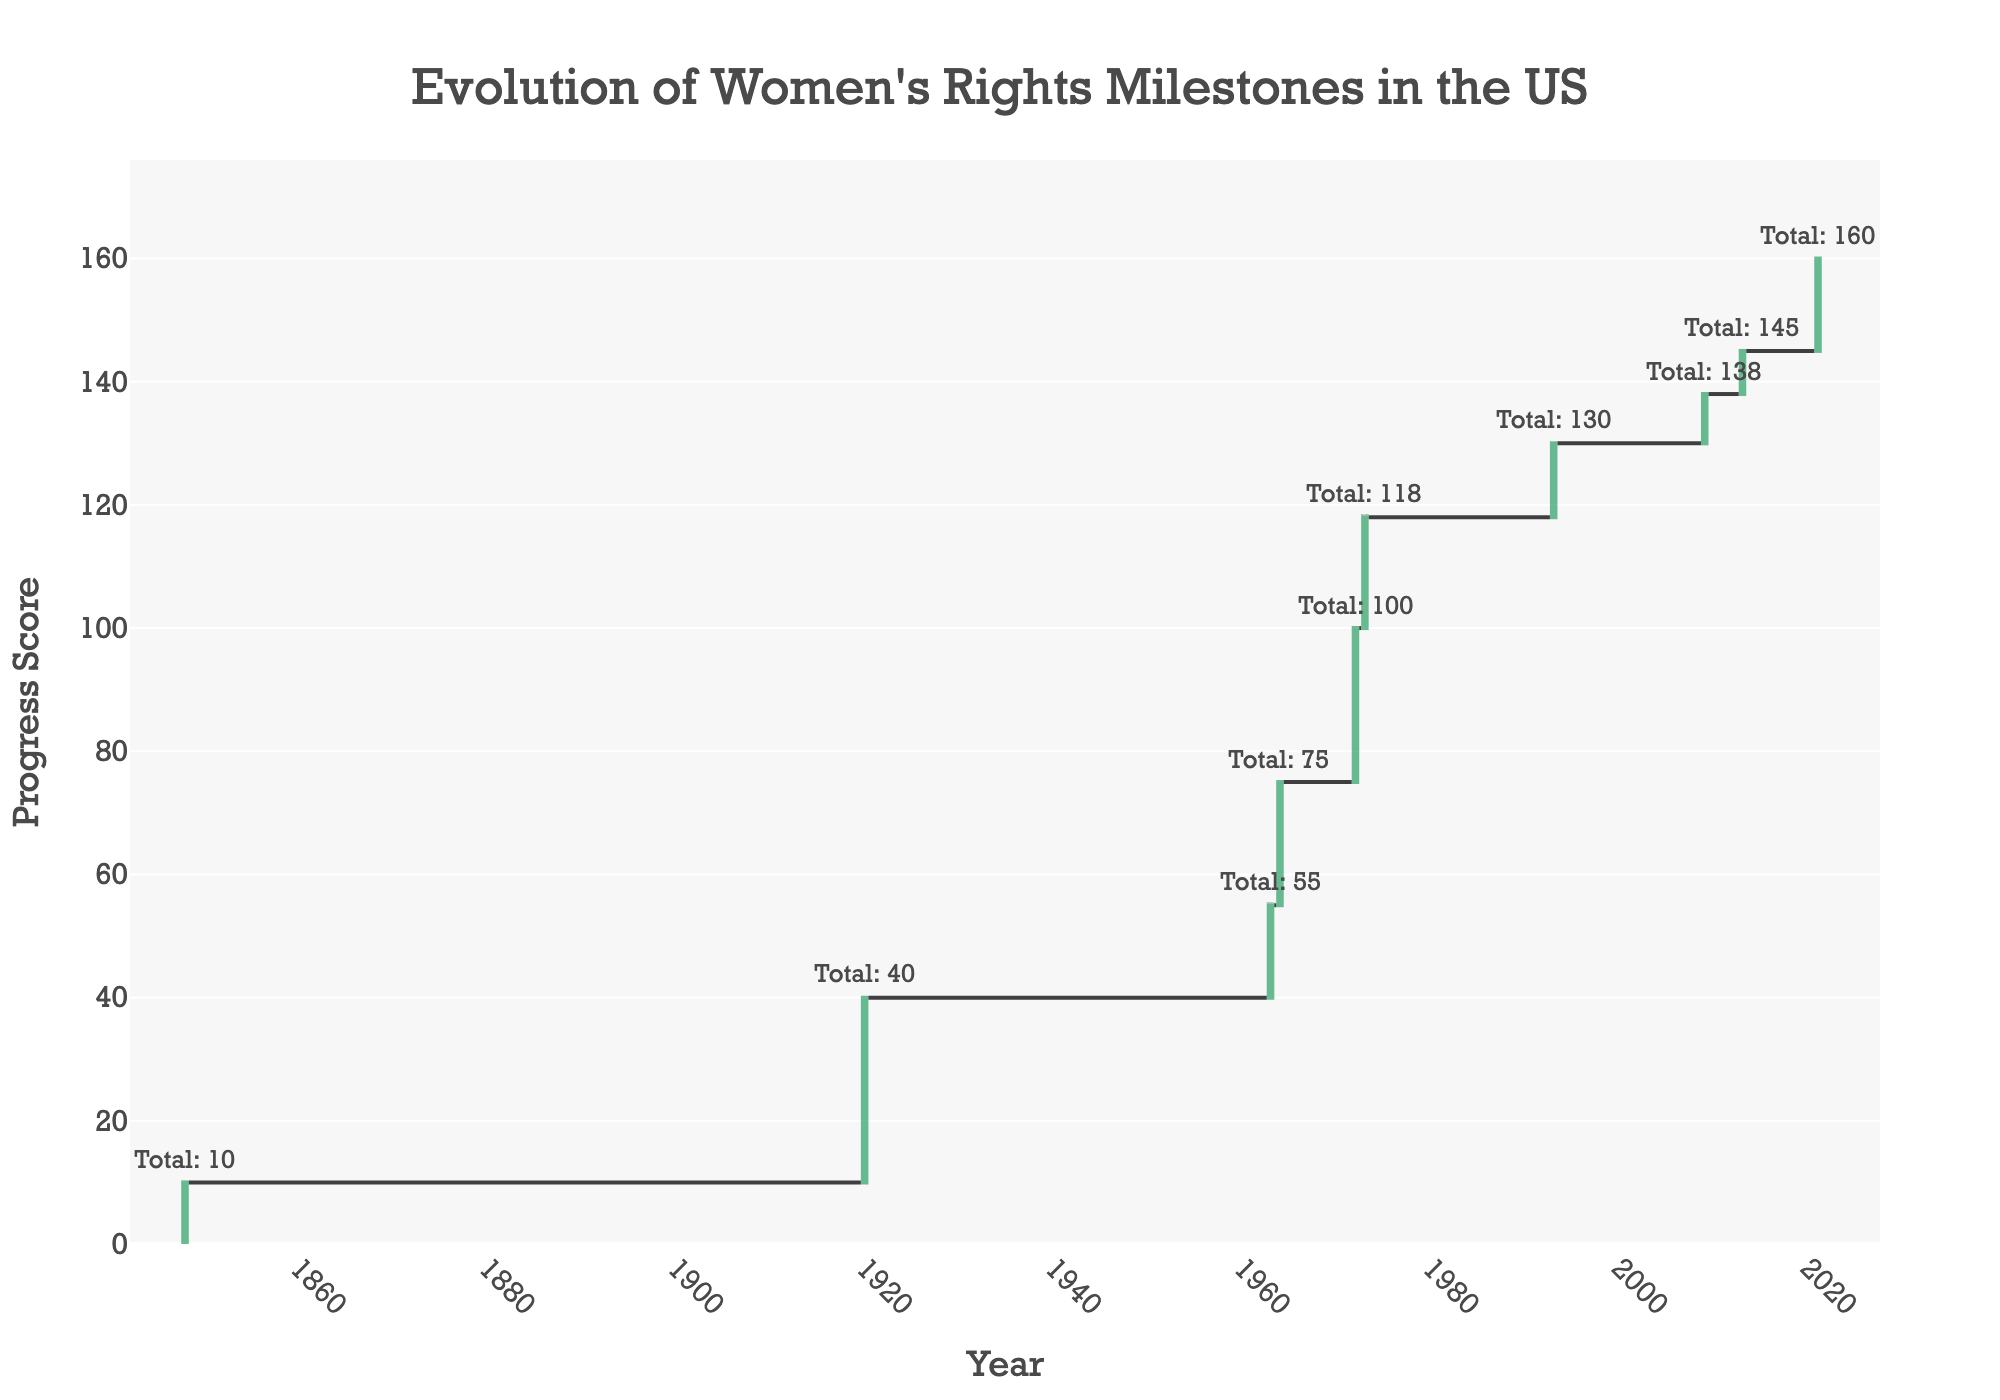What is the title of the chart? The title is prominently displayed at the top of the chart, summarizing the main subject and helping viewers immediately understand what the chart presents. The title of the chart is "Evolution of Women's Rights Milestones in the US."
Answer: Evolution of Women's Rights Milestones in the US In which year did the Seneca Falls Convention occur? Each bar on the x-axis corresponds to a specific year, paired with an event. The Seneca Falls Convention is noted on the x-axis. From the figure, we see it occurred in 1848.
Answer: 1848 How many milestones are marked in this chart? Each data point on the x-axis represents a milestone event. Counting all the data points on the x-axis will give us the total number of milestones. There are 10 data points.
Answer: 10 Which milestone had the largest impact on the progress score? By examining the y-axis, we can see which bar has the highest positive value. The 19th Amendment (Women's Suffrage) in 1920 shows the largest increase with a score of 30.
Answer: 19th Amendment (Women's Suffrage) What is the cumulative progress score by 1973, after Roe v. Wade? The cumulative progress is displayed for each data point. By locating the annotation for 1973, we can see that the total cumulative progress score after Roe v. Wade is given. It is 118.
Answer: 118 What was the cumulative progress score difference between 1963 and 1972? Identify the cumulative scores for both years (1963 and 1972) from their respective annotations. Then find the difference: 70 (1972) - 55 (1963) = 15.
Answer: 15 Compare the progress score changes between the Equal Pay Act in 1963 and the Civil Rights Act Title VII in 1964. Which had a greater impact? Compare the heights of the bars for 1963 and 1964. The Equal Pay Act in 1963 increased the score by 15 and the Civil Rights Act in 1964 by 20. The Civil Rights Act had a greater impact.
Answer: Civil Rights Act Title VII How much did the progress score increase in 2009? Locate the bar for 2009 and read the value on the y-axis. The chart shows an 8-point increase in 2009 due to the Lilly Ledbetter Fair Pay Act.
Answer: 8 What can you infer about women's rights progress based on the cumulative values at the end of the timeline? Observing the increasing cumulative values from 1848 to 2021 indicates a continuous but sometimes fluctuated momentum in the progress of women's rights. The total cumulative score by 2021 reflects significant advancements over time. The cumulative value by 2021 shows 160 points, depicting a steady ascent and adding major milestones.
Answer: Continuous progress, cumulative value 160 Which milestone was achieved more recently, the Family and Medical Leave Act or Women in Combat Roles? From the x-axis, locate the years for both milestones and compare them: the Family and Medical Leave Act was in 1993 and Women in Combat Roles was in 2013. The Women in Combat Roles milestone was achieved more recently.
Answer: Women in Combat Roles 